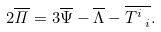Convert formula to latex. <formula><loc_0><loc_0><loc_500><loc_500>2 \overline { \mathit \Pi } = 3 \overline { \Psi } - \overline { \Lambda } - \overline { T ^ { i } _ { \ i } } .</formula> 